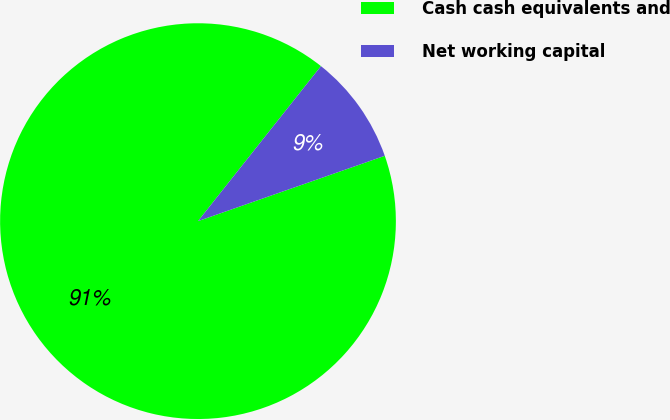Convert chart. <chart><loc_0><loc_0><loc_500><loc_500><pie_chart><fcel>Cash cash equivalents and<fcel>Net working capital<nl><fcel>91.03%<fcel>8.97%<nl></chart> 